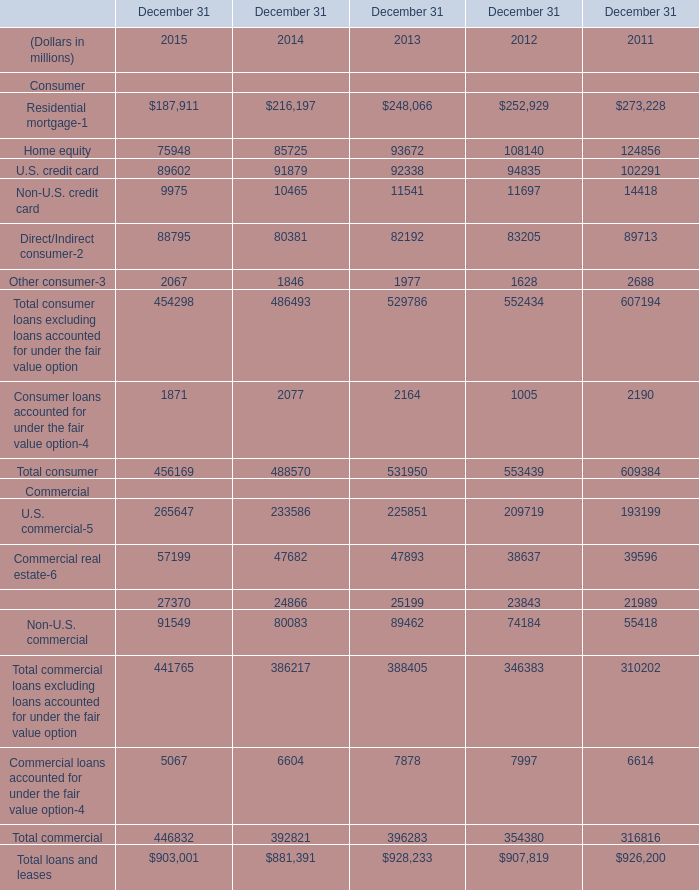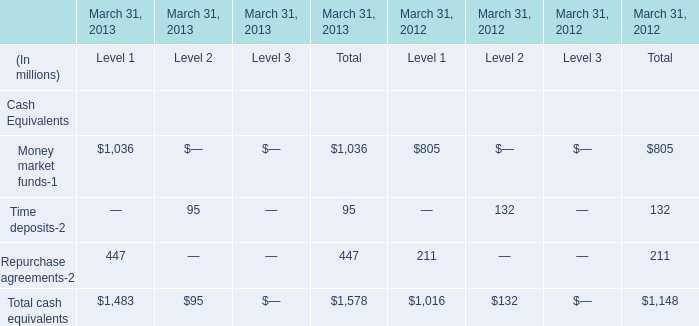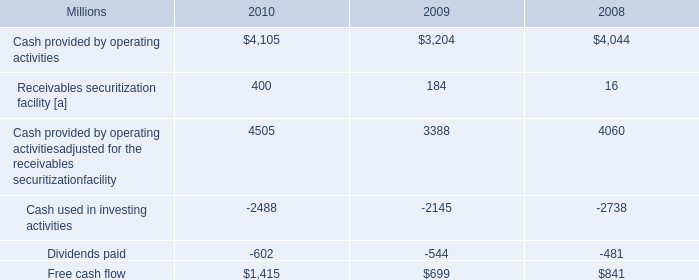What is the total amount of Cash used in investing activities of 2010, U.S. commercial Commercial of December 31 2015, and U.S. commercial Commercial of December 31 2012 ? 
Computations: ((2488.0 + 265647.0) + 209719.0)
Answer: 477854.0. 